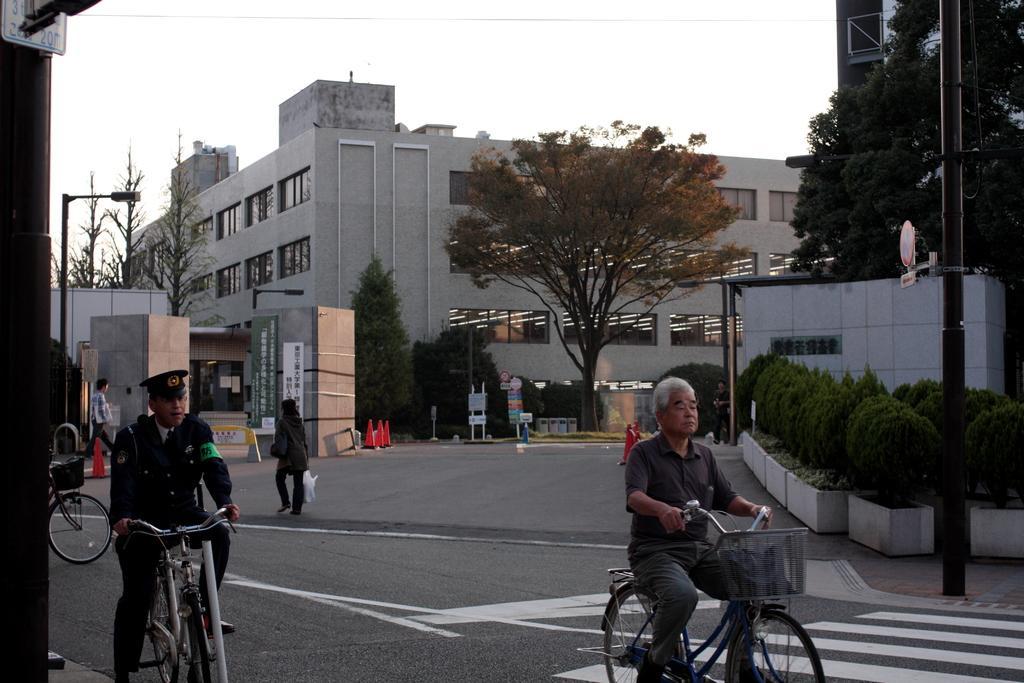Can you describe this image briefly? At the top we can see sky. This is a building. here we can see trees. This is a road. These are traffic cones. Here we can see few boards. We can see two men sitting on bicycle and riding. We can see two persons walking on the road. This is a sign board. These are plants. 